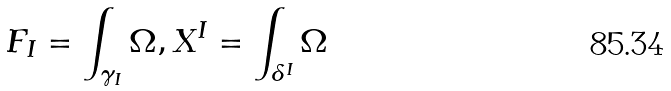<formula> <loc_0><loc_0><loc_500><loc_500>F _ { I } = \int _ { \gamma _ { I } } \Omega , X ^ { I } = \int _ { \delta ^ { I } } \Omega</formula> 